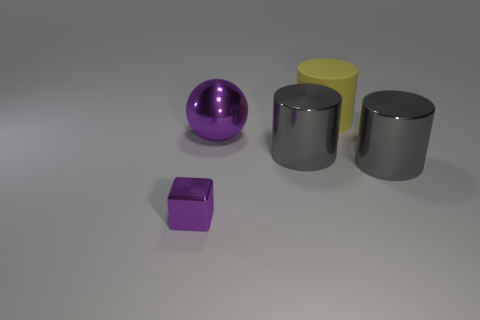Subtract all large gray cylinders. How many cylinders are left? 1 Add 3 tiny green metal spheres. How many objects exist? 8 Subtract all blue spheres. How many gray cylinders are left? 2 Subtract 1 cylinders. How many cylinders are left? 2 Subtract all cylinders. How many objects are left? 2 Subtract all cyan cylinders. Subtract all cyan blocks. How many cylinders are left? 3 Subtract all small cubes. Subtract all big green spheres. How many objects are left? 4 Add 3 matte cylinders. How many matte cylinders are left? 4 Add 2 gray rubber cylinders. How many gray rubber cylinders exist? 2 Subtract 0 red spheres. How many objects are left? 5 